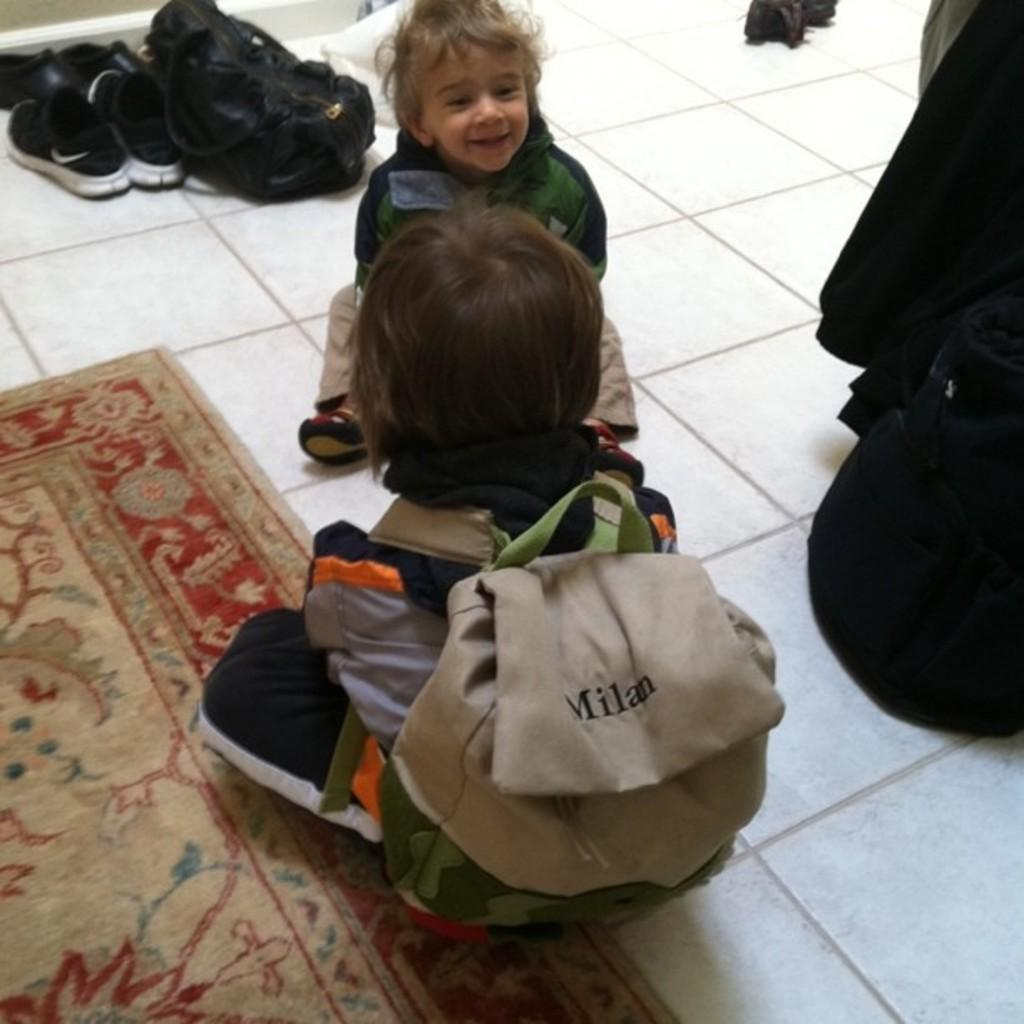Provide a one-sentence caption for the provided image. two toddlers and one has a backpack with Milan on it. 